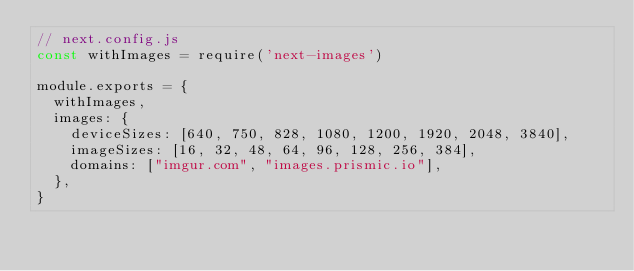Convert code to text. <code><loc_0><loc_0><loc_500><loc_500><_JavaScript_>// next.config.js
const withImages = require('next-images')

module.exports = {
  withImages,
  images: {
    deviceSizes: [640, 750, 828, 1080, 1200, 1920, 2048, 3840],
    imageSizes: [16, 32, 48, 64, 96, 128, 256, 384],
    domains: ["imgur.com", "images.prismic.io"],
  },
}

</code> 